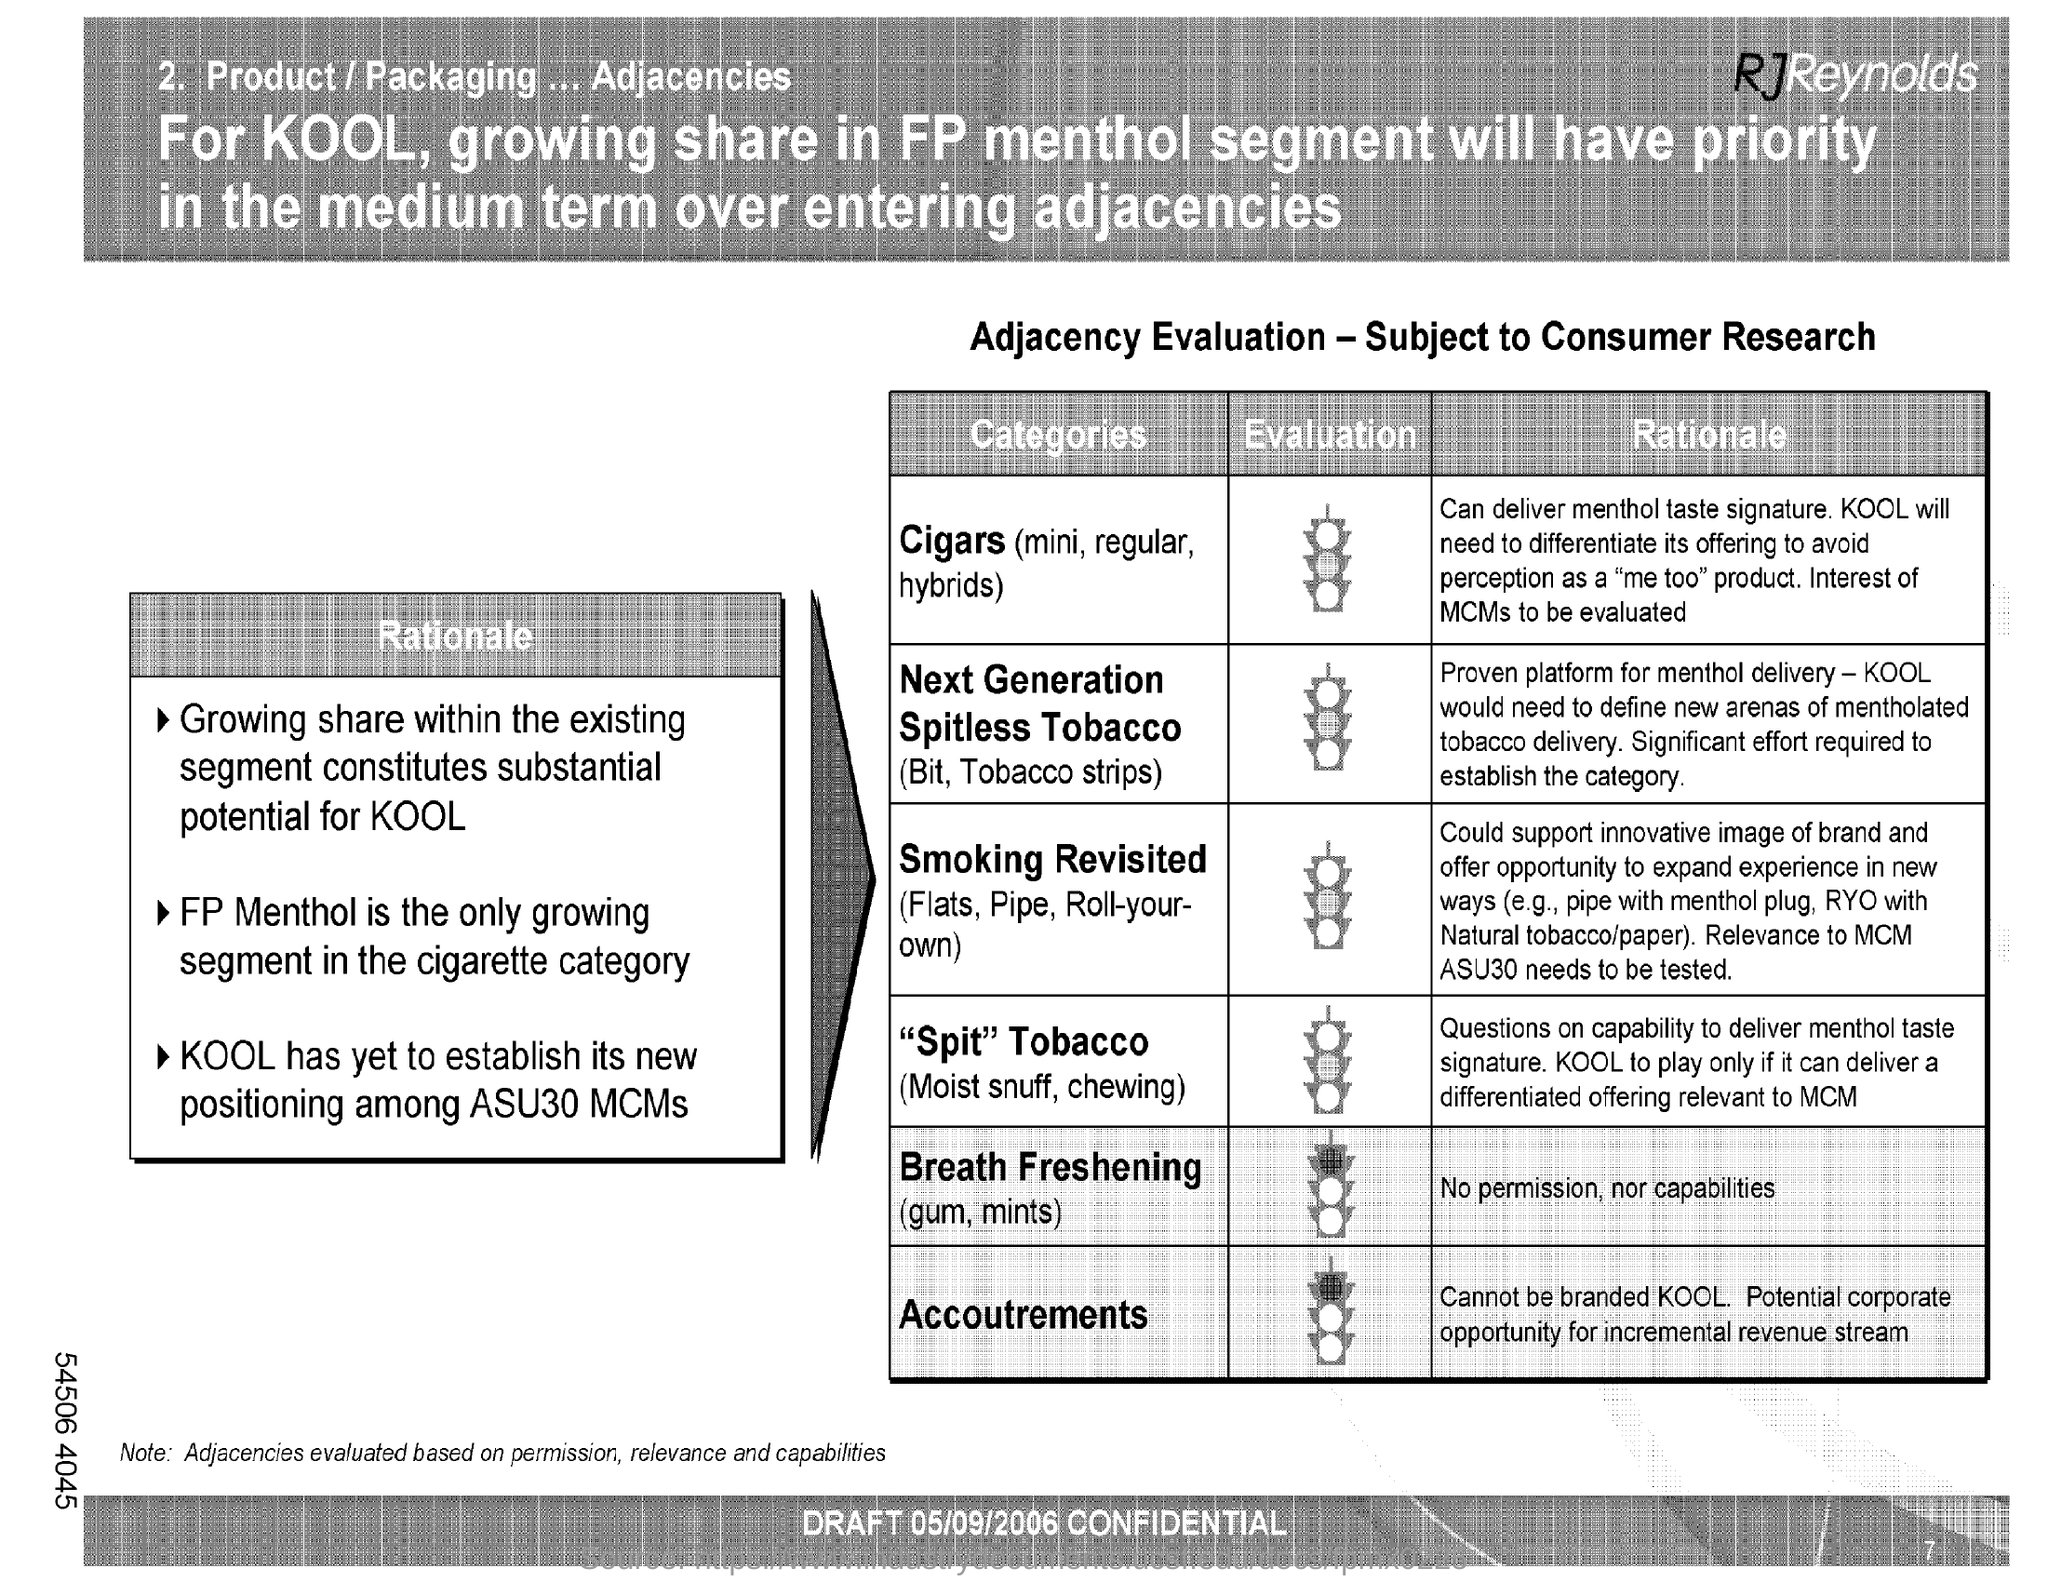When is the draft dated on?
Your answer should be compact. 05/09/2006. 